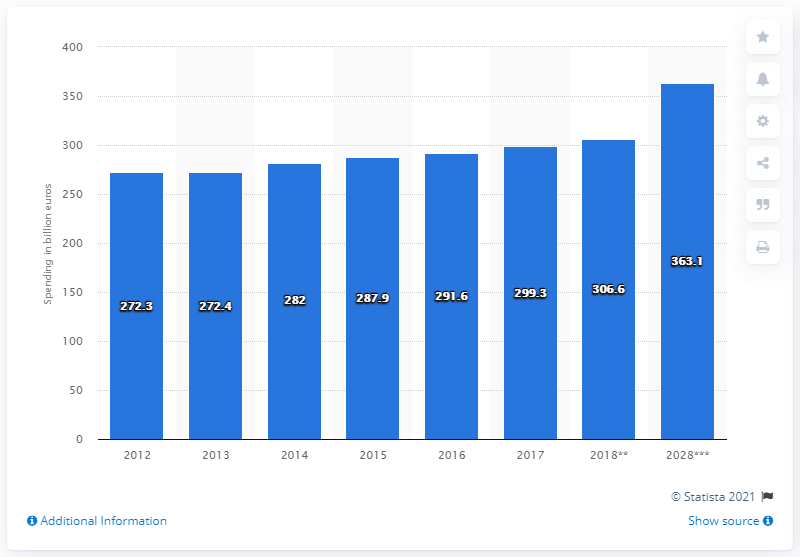Specify some key components in this picture. The second lowest value in the blue bar is 272.4. The difference between the highest and lowest projected expenditure for the given range is 90.8%. In 2017, Germany's domestic travel and tourism spending was 299.3 million. 